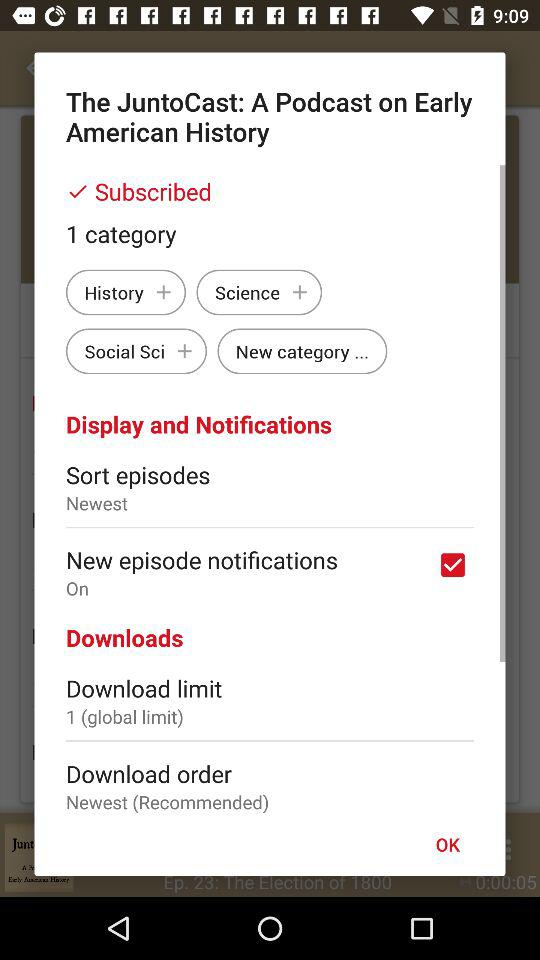When did the newest episode air?
When the provided information is insufficient, respond with <no answer>. <no answer> 